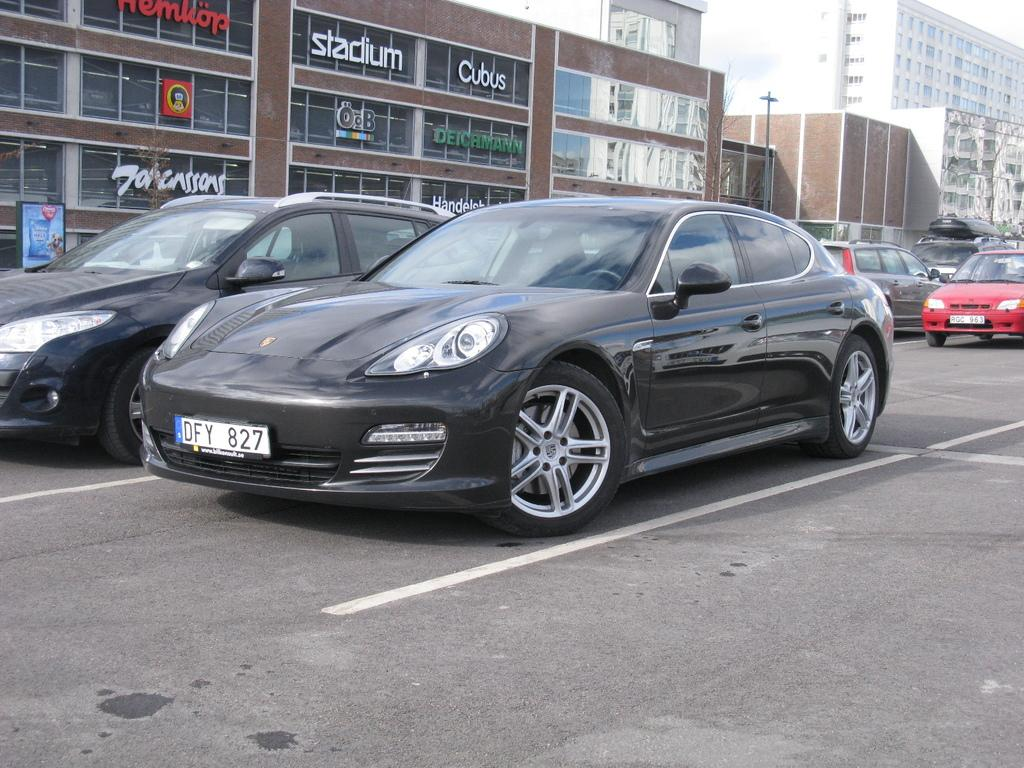What structures are located on the left side of the image? There are buildings on the left side of the image. What can be seen on the road in the image? There are vehicles on the road in the image. Can you describe the blue object in the image? There is a blue board in the image. What type of rhythm can be heard coming from the buildings in the image? There is no indication of sound or rhythm in the image, as it only shows buildings, vehicles, and a blue board. Are there any trains or railway tracks visible in the image? There is no mention of a train or railway tracks in the image, and the term "mark" is unclear in this context. 